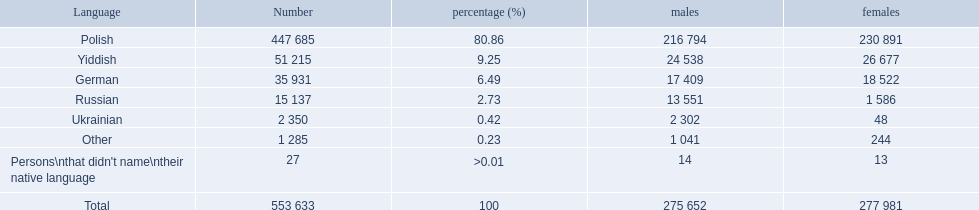What percentages represent the population? 80.86, 9.25, 6.49, 2.73, 0.42, 0.23, >0.01. Which language corresponds to 0.42%? Ukrainian. 